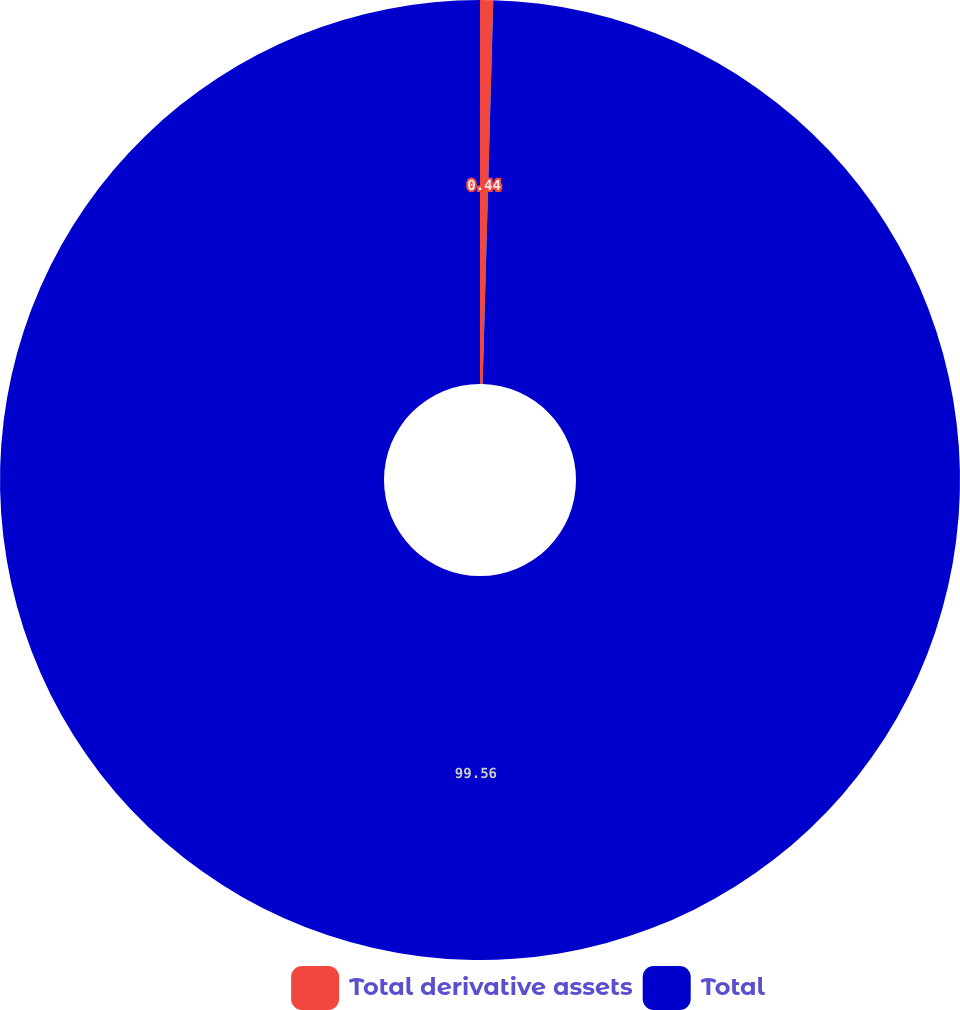Convert chart to OTSL. <chart><loc_0><loc_0><loc_500><loc_500><pie_chart><fcel>Total derivative assets<fcel>Total<nl><fcel>0.44%<fcel>99.56%<nl></chart> 